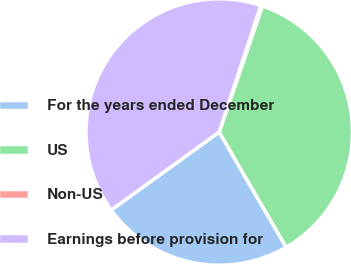<chart> <loc_0><loc_0><loc_500><loc_500><pie_chart><fcel>For the years ended December<fcel>US<fcel>Non-US<fcel>Earnings before provision for<nl><fcel>23.43%<fcel>36.36%<fcel>0.21%<fcel>40.0%<nl></chart> 